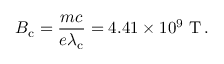Convert formula to latex. <formula><loc_0><loc_0><loc_500><loc_500>B _ { c } = { \frac { m c } { e \lambda _ { c } } } = 4 . 4 1 \times 1 0 ^ { 9 } { T } \, .</formula> 